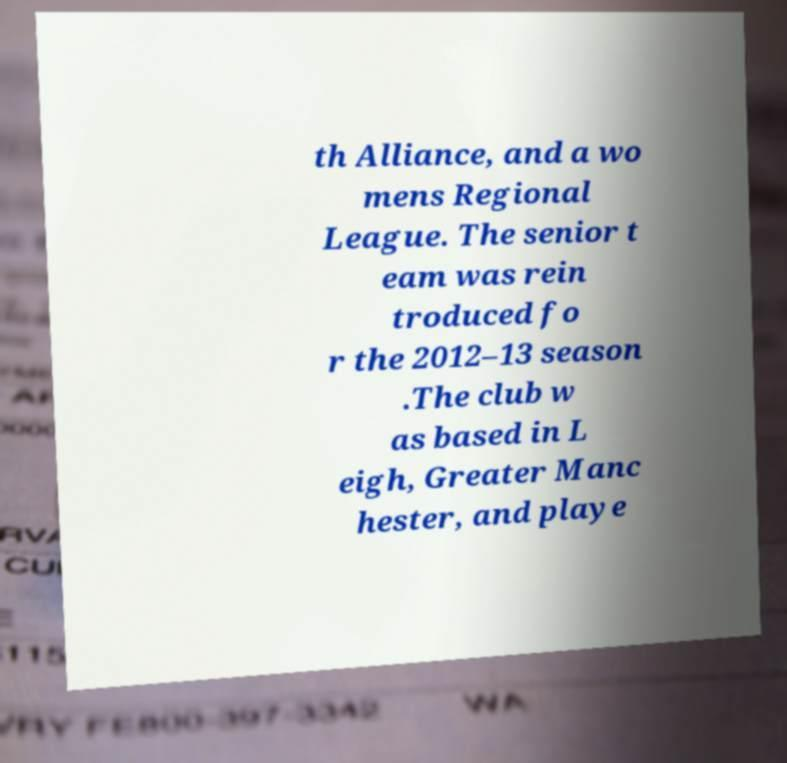Please read and relay the text visible in this image. What does it say? th Alliance, and a wo mens Regional League. The senior t eam was rein troduced fo r the 2012–13 season .The club w as based in L eigh, Greater Manc hester, and playe 